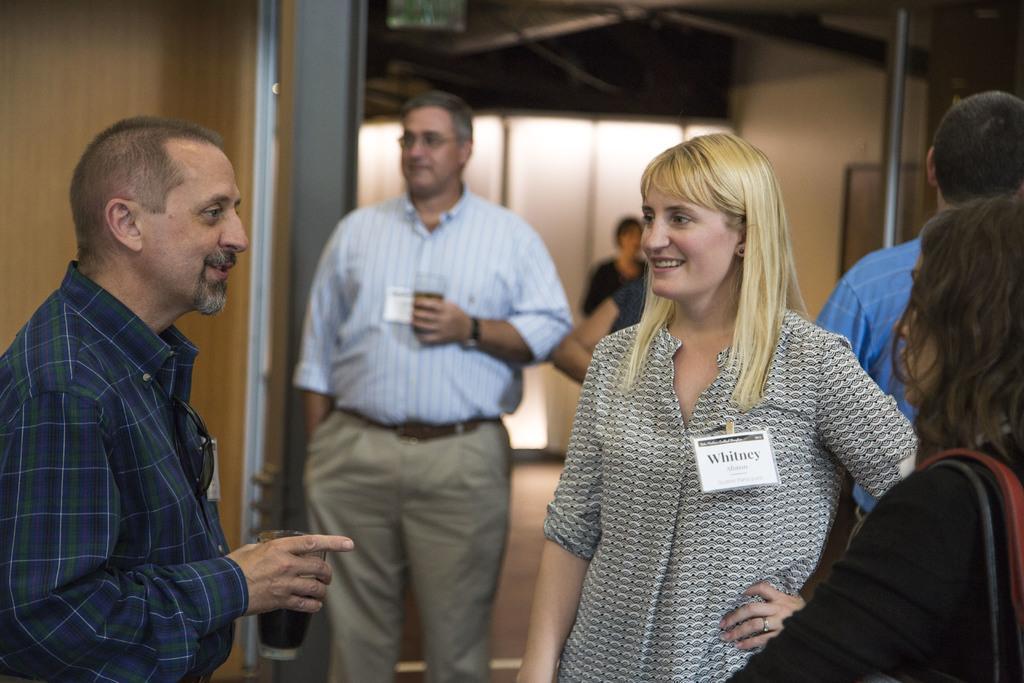How would you summarize this image in a sentence or two? In this image we can see people standing on the floor and some of them are holding glass tumblers in the hands. 